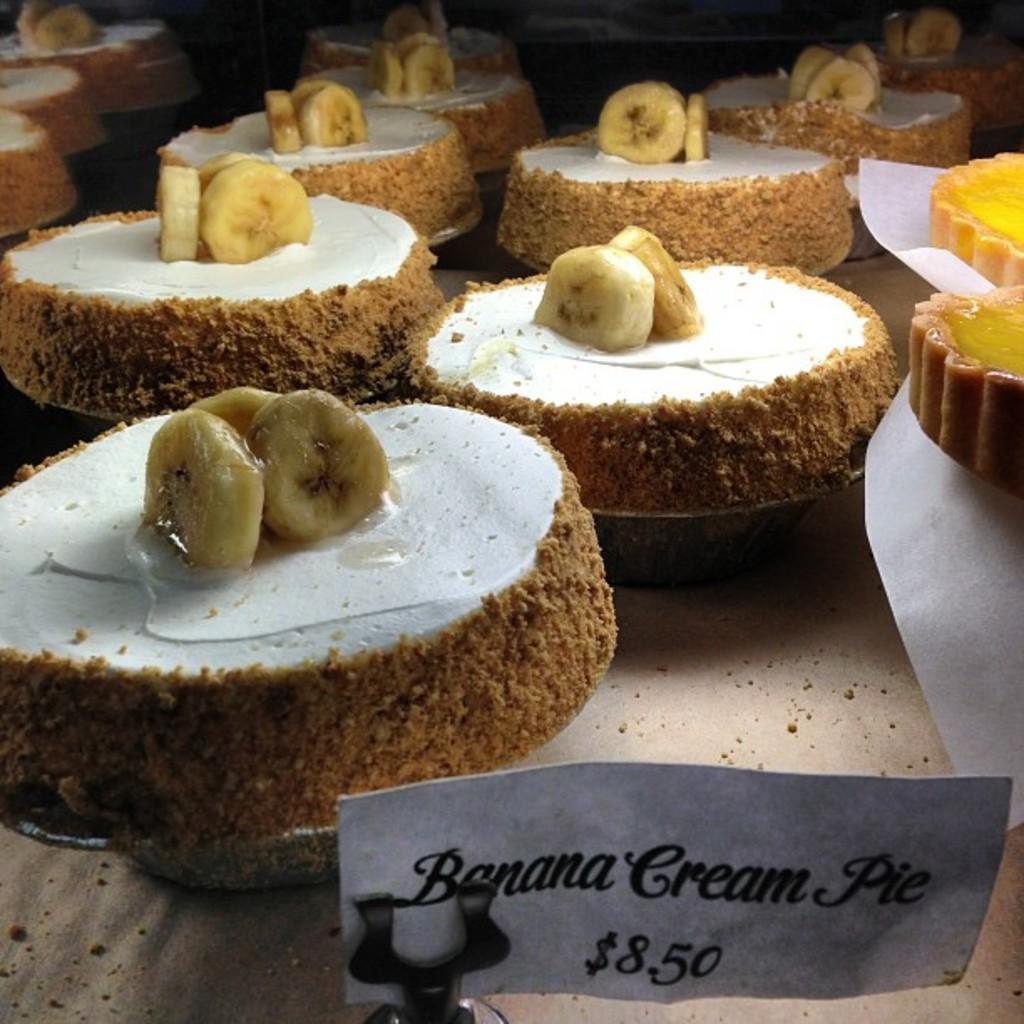Please provide a concise description of this image. In this image we can see group of food items placed on a table. In the foreground we can see a paper with some text on it. 